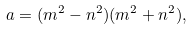Convert formula to latex. <formula><loc_0><loc_0><loc_500><loc_500>a = ( m ^ { 2 } - n ^ { 2 } ) ( m ^ { 2 } + n ^ { 2 } ) ,</formula> 